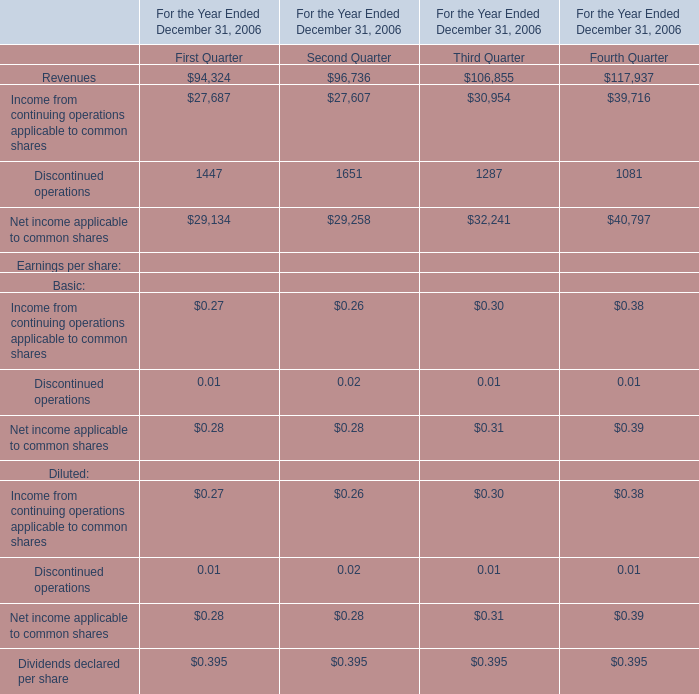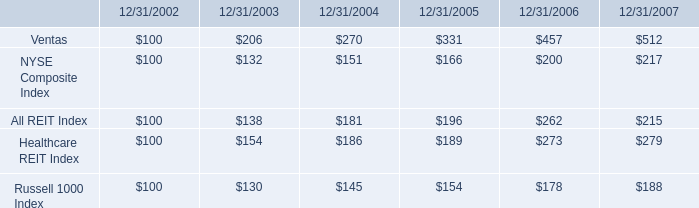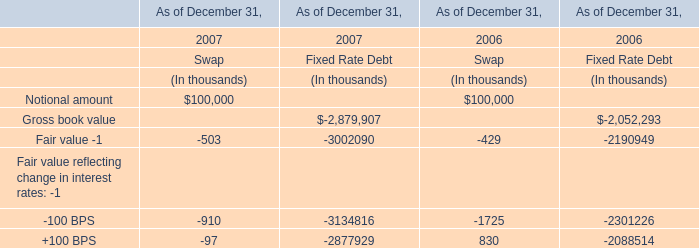What do all Revenues sum up in 2006 , excluding Third Quarter and Fourth Quarte 
Computations: (94324 + 96736)
Answer: 191060.0. 